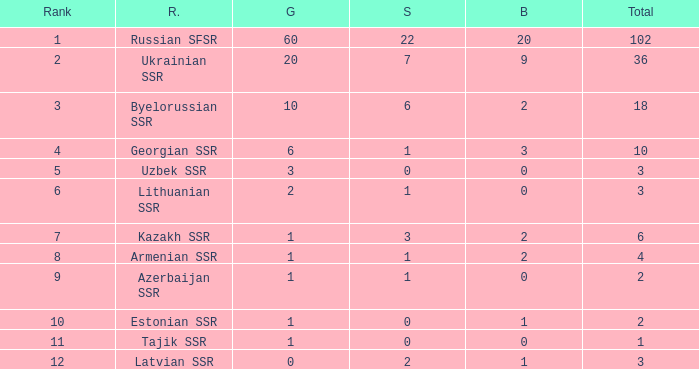Write the full table. {'header': ['Rank', 'R.', 'G', 'S', 'B', 'Total'], 'rows': [['1', 'Russian SFSR', '60', '22', '20', '102'], ['2', 'Ukrainian SSR', '20', '7', '9', '36'], ['3', 'Byelorussian SSR', '10', '6', '2', '18'], ['4', 'Georgian SSR', '6', '1', '3', '10'], ['5', 'Uzbek SSR', '3', '0', '0', '3'], ['6', 'Lithuanian SSR', '2', '1', '0', '3'], ['7', 'Kazakh SSR', '1', '3', '2', '6'], ['8', 'Armenian SSR', '1', '1', '2', '4'], ['9', 'Azerbaijan SSR', '1', '1', '0', '2'], ['10', 'Estonian SSR', '1', '0', '1', '2'], ['11', 'Tajik SSR', '1', '0', '0', '1'], ['12', 'Latvian SSR', '0', '2', '1', '3']]} What is the average total for teams with more than 1 gold, ranked over 3 and more than 3 bronze? None. 